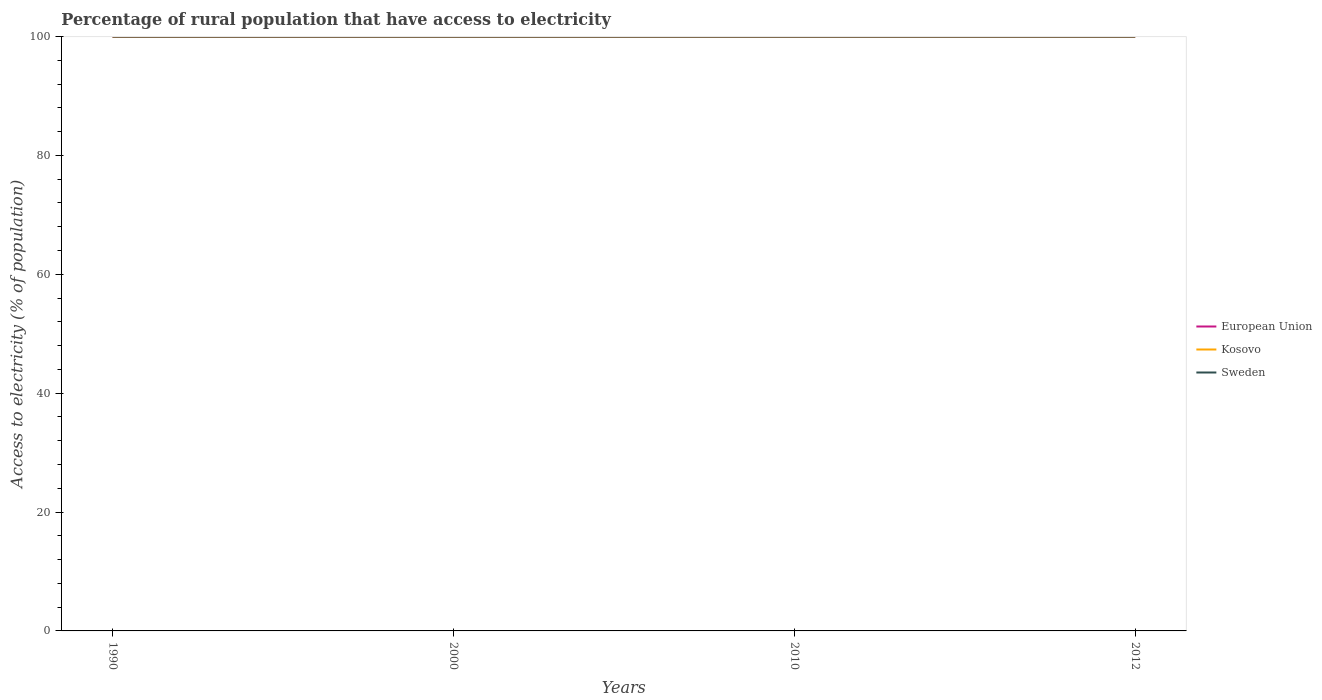Does the line corresponding to Kosovo intersect with the line corresponding to Sweden?
Offer a terse response. Yes. Across all years, what is the maximum percentage of rural population that have access to electricity in European Union?
Give a very brief answer. 99.99. In which year was the percentage of rural population that have access to electricity in Sweden maximum?
Your answer should be very brief. 1990. What is the difference between the highest and the second highest percentage of rural population that have access to electricity in Kosovo?
Ensure brevity in your answer.  0. Is the percentage of rural population that have access to electricity in European Union strictly greater than the percentage of rural population that have access to electricity in Sweden over the years?
Offer a very short reply. No. How many lines are there?
Offer a very short reply. 3. How many years are there in the graph?
Offer a very short reply. 4. What is the difference between two consecutive major ticks on the Y-axis?
Keep it short and to the point. 20. Are the values on the major ticks of Y-axis written in scientific E-notation?
Make the answer very short. No. Does the graph contain any zero values?
Give a very brief answer. No. Does the graph contain grids?
Offer a very short reply. No. Where does the legend appear in the graph?
Provide a succinct answer. Center right. How many legend labels are there?
Your answer should be compact. 3. What is the title of the graph?
Keep it short and to the point. Percentage of rural population that have access to electricity. Does "Sub-Saharan Africa (all income levels)" appear as one of the legend labels in the graph?
Your answer should be compact. No. What is the label or title of the Y-axis?
Ensure brevity in your answer.  Access to electricity (% of population). What is the Access to electricity (% of population) in European Union in 1990?
Provide a succinct answer. 99.99. What is the Access to electricity (% of population) of Kosovo in 1990?
Offer a terse response. 100. What is the Access to electricity (% of population) in Sweden in 1990?
Offer a terse response. 100. What is the Access to electricity (% of population) in European Union in 2000?
Keep it short and to the point. 100. What is the Access to electricity (% of population) in Kosovo in 2000?
Give a very brief answer. 100. What is the Access to electricity (% of population) in European Union in 2010?
Keep it short and to the point. 100. What is the Access to electricity (% of population) of Kosovo in 2010?
Ensure brevity in your answer.  100. What is the Access to electricity (% of population) of European Union in 2012?
Your answer should be compact. 100. What is the Access to electricity (% of population) in Kosovo in 2012?
Keep it short and to the point. 100. Across all years, what is the maximum Access to electricity (% of population) in European Union?
Ensure brevity in your answer.  100. Across all years, what is the maximum Access to electricity (% of population) in Kosovo?
Provide a short and direct response. 100. Across all years, what is the minimum Access to electricity (% of population) of European Union?
Ensure brevity in your answer.  99.99. Across all years, what is the minimum Access to electricity (% of population) in Sweden?
Offer a very short reply. 100. What is the total Access to electricity (% of population) of European Union in the graph?
Your answer should be compact. 399.99. What is the total Access to electricity (% of population) in Sweden in the graph?
Give a very brief answer. 400. What is the difference between the Access to electricity (% of population) of European Union in 1990 and that in 2000?
Your answer should be compact. -0.01. What is the difference between the Access to electricity (% of population) of European Union in 1990 and that in 2010?
Offer a very short reply. -0.01. What is the difference between the Access to electricity (% of population) in Kosovo in 1990 and that in 2010?
Your response must be concise. 0. What is the difference between the Access to electricity (% of population) of Sweden in 1990 and that in 2010?
Provide a succinct answer. 0. What is the difference between the Access to electricity (% of population) of European Union in 1990 and that in 2012?
Offer a terse response. -0.01. What is the difference between the Access to electricity (% of population) of Kosovo in 1990 and that in 2012?
Offer a very short reply. 0. What is the difference between the Access to electricity (% of population) of European Union in 2000 and that in 2010?
Your answer should be compact. 0. What is the difference between the Access to electricity (% of population) of Sweden in 2000 and that in 2010?
Offer a very short reply. 0. What is the difference between the Access to electricity (% of population) in Kosovo in 2000 and that in 2012?
Give a very brief answer. 0. What is the difference between the Access to electricity (% of population) in Sweden in 2000 and that in 2012?
Your answer should be very brief. 0. What is the difference between the Access to electricity (% of population) in Sweden in 2010 and that in 2012?
Your answer should be very brief. 0. What is the difference between the Access to electricity (% of population) in European Union in 1990 and the Access to electricity (% of population) in Kosovo in 2000?
Offer a terse response. -0.01. What is the difference between the Access to electricity (% of population) of European Union in 1990 and the Access to electricity (% of population) of Sweden in 2000?
Provide a short and direct response. -0.01. What is the difference between the Access to electricity (% of population) of European Union in 1990 and the Access to electricity (% of population) of Kosovo in 2010?
Provide a short and direct response. -0.01. What is the difference between the Access to electricity (% of population) of European Union in 1990 and the Access to electricity (% of population) of Sweden in 2010?
Offer a very short reply. -0.01. What is the difference between the Access to electricity (% of population) in Kosovo in 1990 and the Access to electricity (% of population) in Sweden in 2010?
Offer a very short reply. 0. What is the difference between the Access to electricity (% of population) of European Union in 1990 and the Access to electricity (% of population) of Kosovo in 2012?
Ensure brevity in your answer.  -0.01. What is the difference between the Access to electricity (% of population) of European Union in 1990 and the Access to electricity (% of population) of Sweden in 2012?
Your response must be concise. -0.01. What is the difference between the Access to electricity (% of population) of European Union in 2000 and the Access to electricity (% of population) of Sweden in 2010?
Make the answer very short. 0. What is the difference between the Access to electricity (% of population) in European Union in 2010 and the Access to electricity (% of population) in Kosovo in 2012?
Give a very brief answer. 0. What is the difference between the Access to electricity (% of population) of Kosovo in 2010 and the Access to electricity (% of population) of Sweden in 2012?
Offer a very short reply. 0. What is the average Access to electricity (% of population) of European Union per year?
Ensure brevity in your answer.  100. What is the average Access to electricity (% of population) of Kosovo per year?
Offer a terse response. 100. In the year 1990, what is the difference between the Access to electricity (% of population) in European Union and Access to electricity (% of population) in Kosovo?
Your answer should be very brief. -0.01. In the year 1990, what is the difference between the Access to electricity (% of population) in European Union and Access to electricity (% of population) in Sweden?
Your answer should be compact. -0.01. In the year 2000, what is the difference between the Access to electricity (% of population) of European Union and Access to electricity (% of population) of Kosovo?
Your response must be concise. 0. In the year 2010, what is the difference between the Access to electricity (% of population) in European Union and Access to electricity (% of population) in Kosovo?
Make the answer very short. 0. In the year 2012, what is the difference between the Access to electricity (% of population) of European Union and Access to electricity (% of population) of Kosovo?
Provide a short and direct response. 0. In the year 2012, what is the difference between the Access to electricity (% of population) of Kosovo and Access to electricity (% of population) of Sweden?
Your answer should be compact. 0. What is the ratio of the Access to electricity (% of population) in European Union in 1990 to that in 2010?
Your answer should be very brief. 1. What is the ratio of the Access to electricity (% of population) in Sweden in 1990 to that in 2010?
Your answer should be compact. 1. What is the ratio of the Access to electricity (% of population) in Kosovo in 1990 to that in 2012?
Your answer should be very brief. 1. What is the ratio of the Access to electricity (% of population) in Sweden in 1990 to that in 2012?
Offer a very short reply. 1. What is the ratio of the Access to electricity (% of population) of Kosovo in 2000 to that in 2010?
Offer a very short reply. 1. What is the ratio of the Access to electricity (% of population) of Sweden in 2000 to that in 2010?
Give a very brief answer. 1. What is the ratio of the Access to electricity (% of population) of European Union in 2000 to that in 2012?
Provide a succinct answer. 1. What is the ratio of the Access to electricity (% of population) in Kosovo in 2000 to that in 2012?
Offer a very short reply. 1. What is the difference between the highest and the lowest Access to electricity (% of population) in European Union?
Give a very brief answer. 0.01. What is the difference between the highest and the lowest Access to electricity (% of population) in Kosovo?
Keep it short and to the point. 0. 